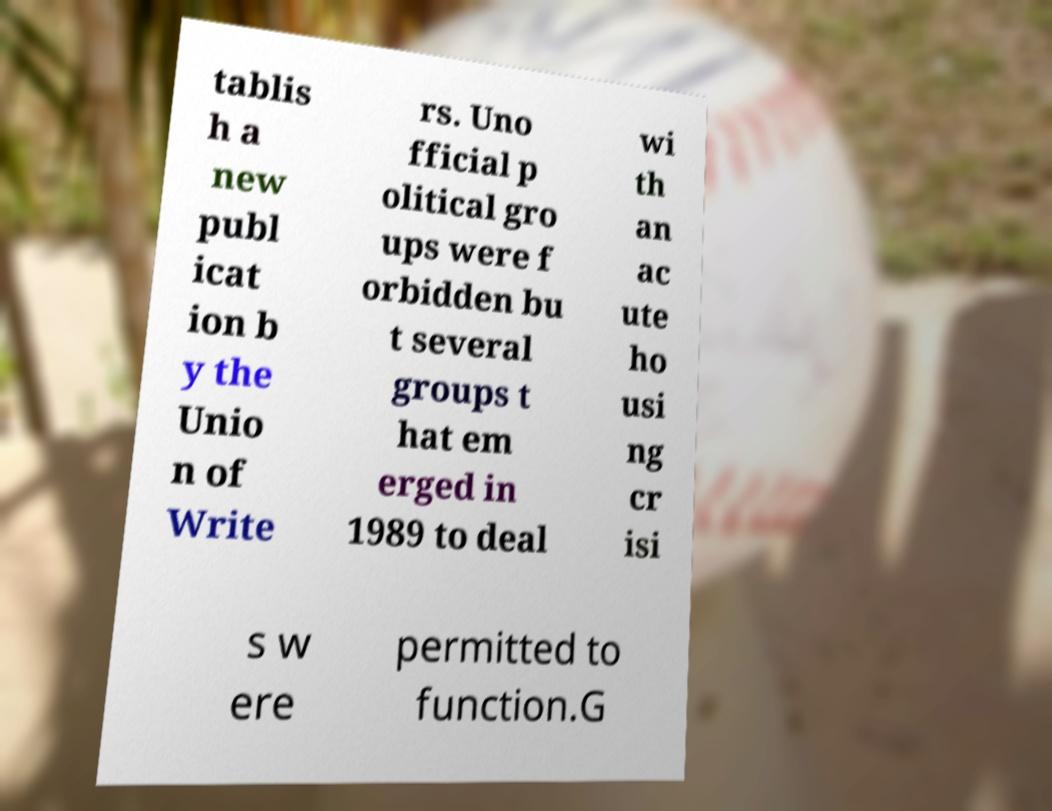I need the written content from this picture converted into text. Can you do that? tablis h a new publ icat ion b y the Unio n of Write rs. Uno fficial p olitical gro ups were f orbidden bu t several groups t hat em erged in 1989 to deal wi th an ac ute ho usi ng cr isi s w ere permitted to function.G 